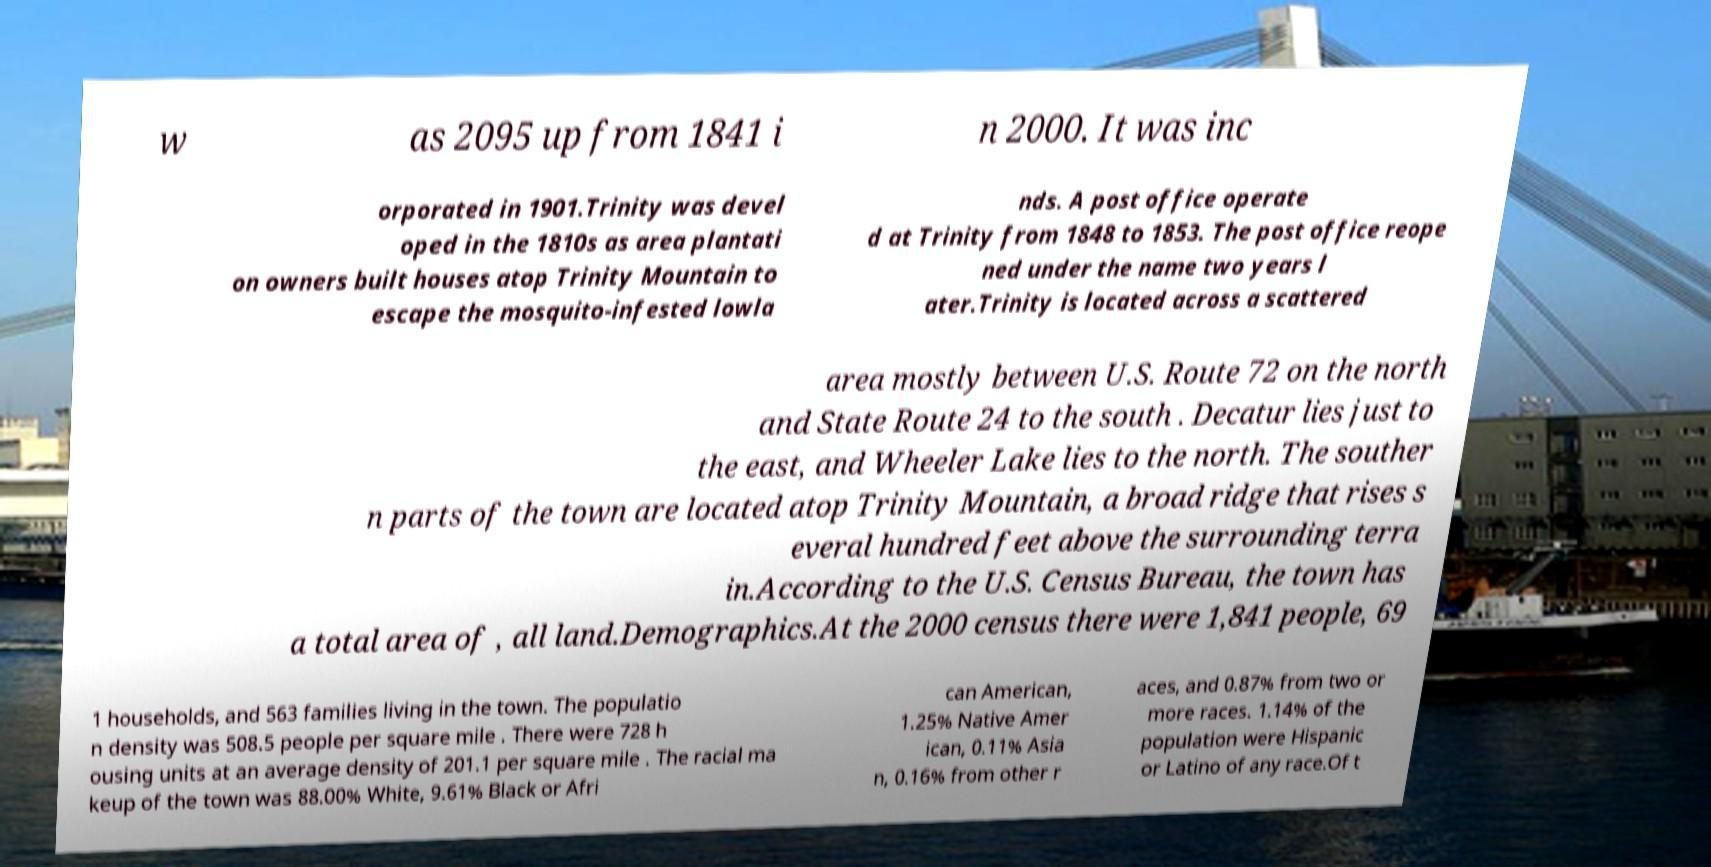What messages or text are displayed in this image? I need them in a readable, typed format. w as 2095 up from 1841 i n 2000. It was inc orporated in 1901.Trinity was devel oped in the 1810s as area plantati on owners built houses atop Trinity Mountain to escape the mosquito-infested lowla nds. A post office operate d at Trinity from 1848 to 1853. The post office reope ned under the name two years l ater.Trinity is located across a scattered area mostly between U.S. Route 72 on the north and State Route 24 to the south . Decatur lies just to the east, and Wheeler Lake lies to the north. The souther n parts of the town are located atop Trinity Mountain, a broad ridge that rises s everal hundred feet above the surrounding terra in.According to the U.S. Census Bureau, the town has a total area of , all land.Demographics.At the 2000 census there were 1,841 people, 69 1 households, and 563 families living in the town. The populatio n density was 508.5 people per square mile . There were 728 h ousing units at an average density of 201.1 per square mile . The racial ma keup of the town was 88.00% White, 9.61% Black or Afri can American, 1.25% Native Amer ican, 0.11% Asia n, 0.16% from other r aces, and 0.87% from two or more races. 1.14% of the population were Hispanic or Latino of any race.Of t 